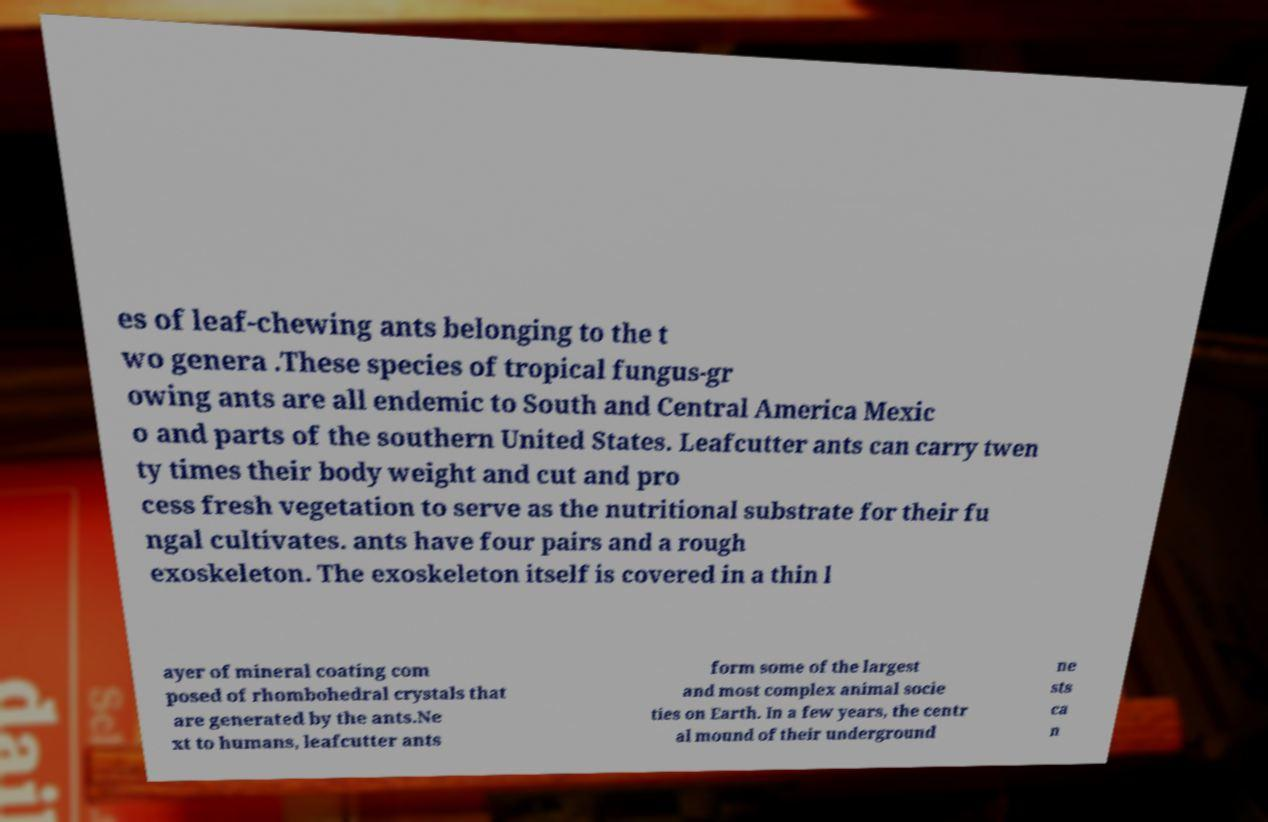Can you accurately transcribe the text from the provided image for me? es of leaf-chewing ants belonging to the t wo genera .These species of tropical fungus-gr owing ants are all endemic to South and Central America Mexic o and parts of the southern United States. Leafcutter ants can carry twen ty times their body weight and cut and pro cess fresh vegetation to serve as the nutritional substrate for their fu ngal cultivates. ants have four pairs and a rough exoskeleton. The exoskeleton itself is covered in a thin l ayer of mineral coating com posed of rhombohedral crystals that are generated by the ants.Ne xt to humans, leafcutter ants form some of the largest and most complex animal socie ties on Earth. In a few years, the centr al mound of their underground ne sts ca n 